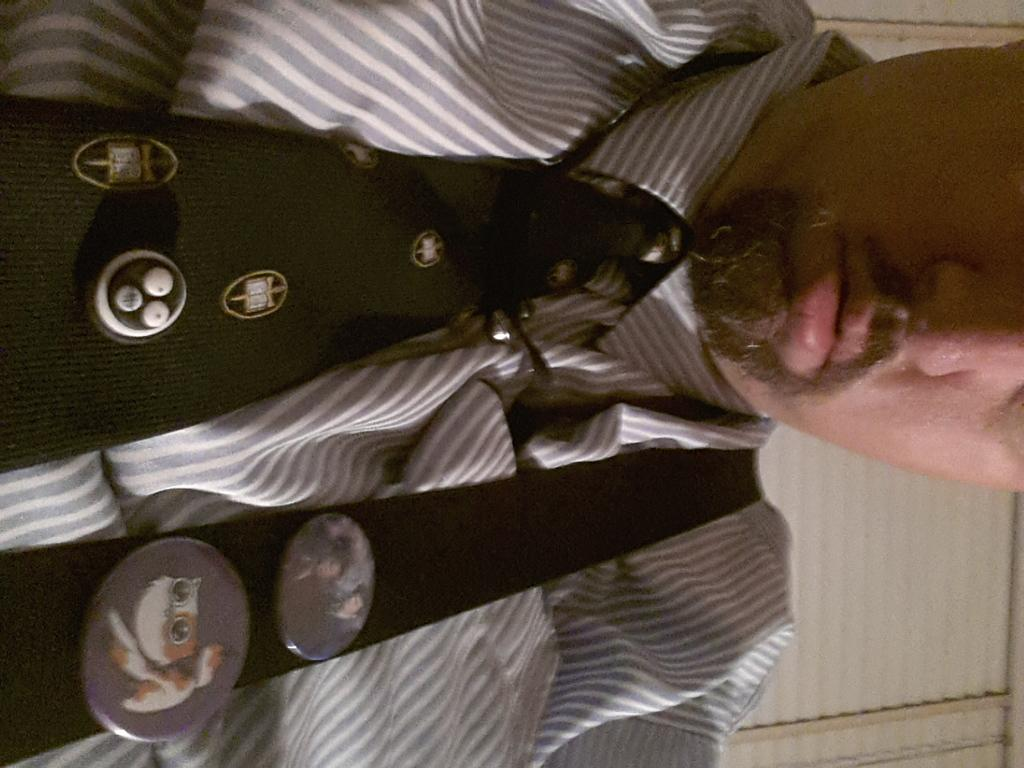Who is present in the image? There is a man in the image. What type of cheese is being delivered to the mailbox in the image? There is no cheese or mailbox present in the image; it only features a man. 